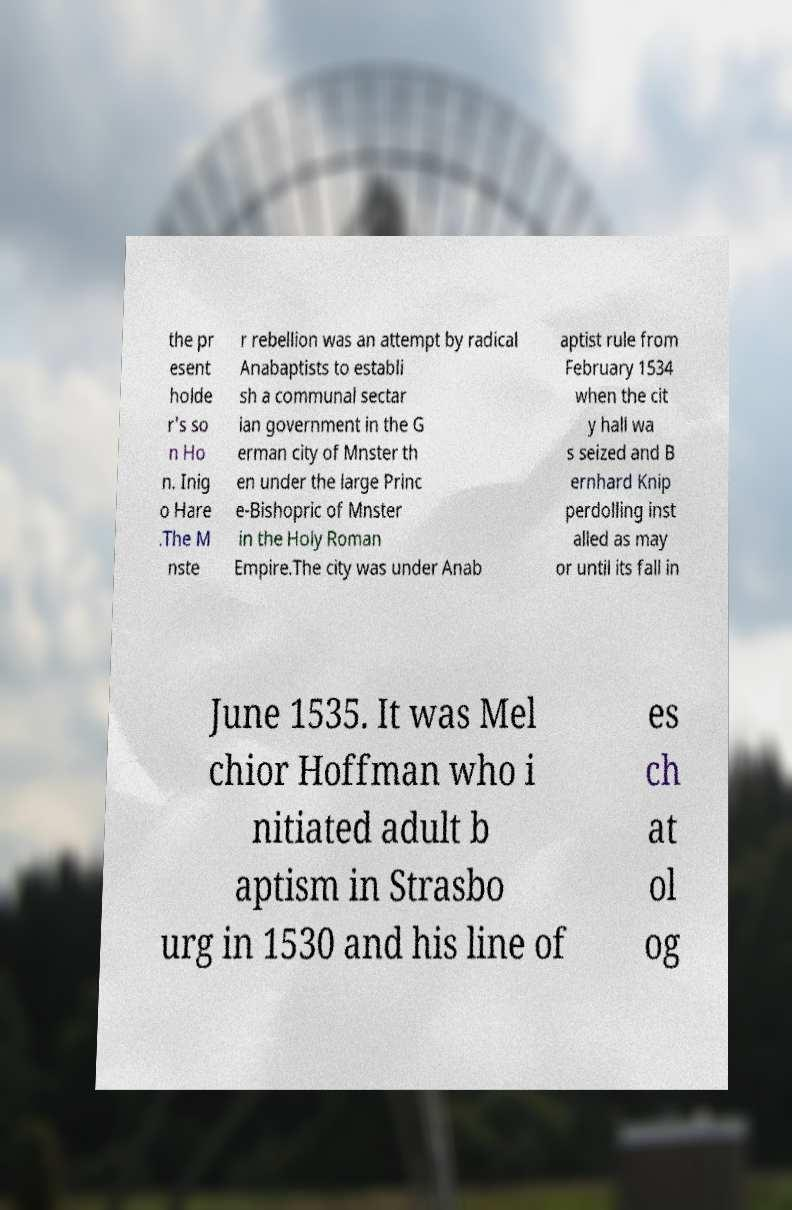I need the written content from this picture converted into text. Can you do that? the pr esent holde r's so n Ho n. Inig o Hare .The M nste r rebellion was an attempt by radical Anabaptists to establi sh a communal sectar ian government in the G erman city of Mnster th en under the large Princ e-Bishopric of Mnster in the Holy Roman Empire.The city was under Anab aptist rule from February 1534 when the cit y hall wa s seized and B ernhard Knip perdolling inst alled as may or until its fall in June 1535. It was Mel chior Hoffman who i nitiated adult b aptism in Strasbo urg in 1530 and his line of es ch at ol og 